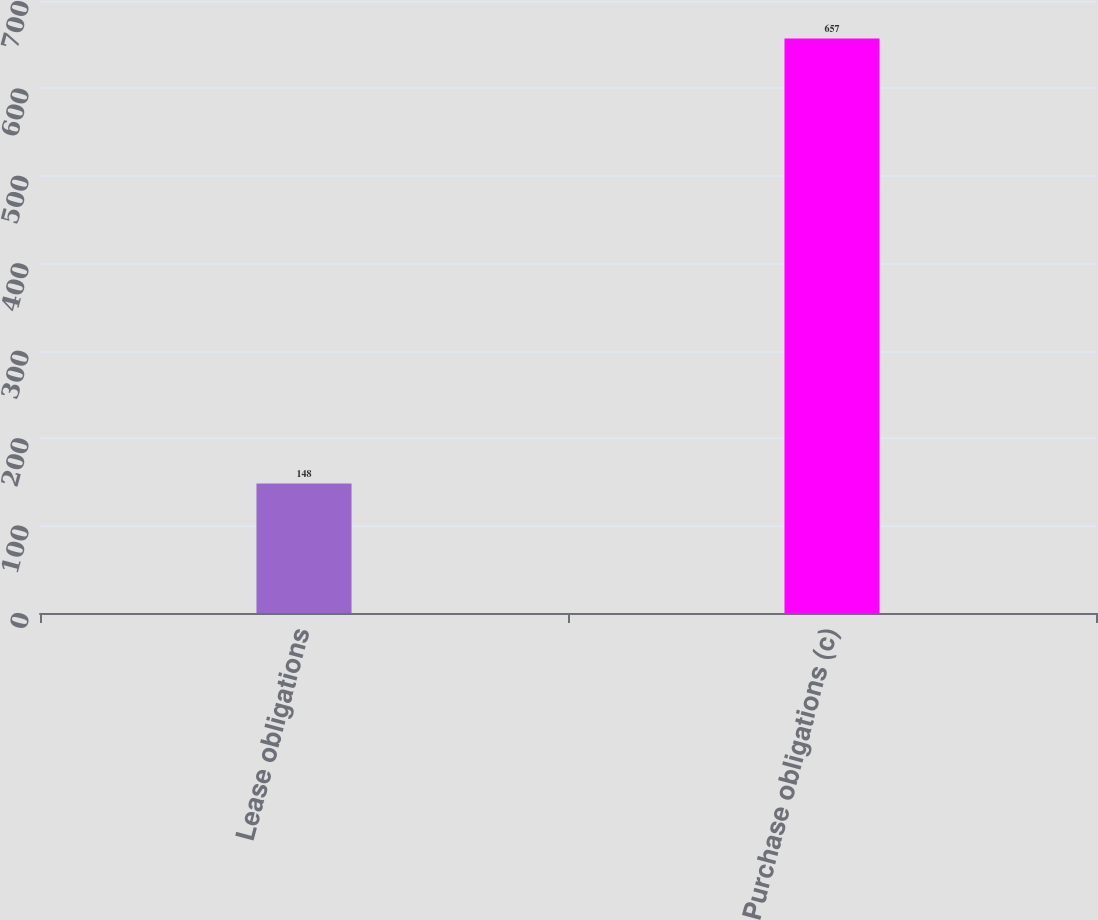Convert chart to OTSL. <chart><loc_0><loc_0><loc_500><loc_500><bar_chart><fcel>Lease obligations<fcel>Purchase obligations (c)<nl><fcel>148<fcel>657<nl></chart> 